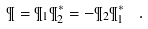<formula> <loc_0><loc_0><loc_500><loc_500>\P = \P _ { 1 } \P _ { 2 } ^ { * } = - \P _ { 2 } \P _ { 1 } ^ { * } \ \ .</formula> 